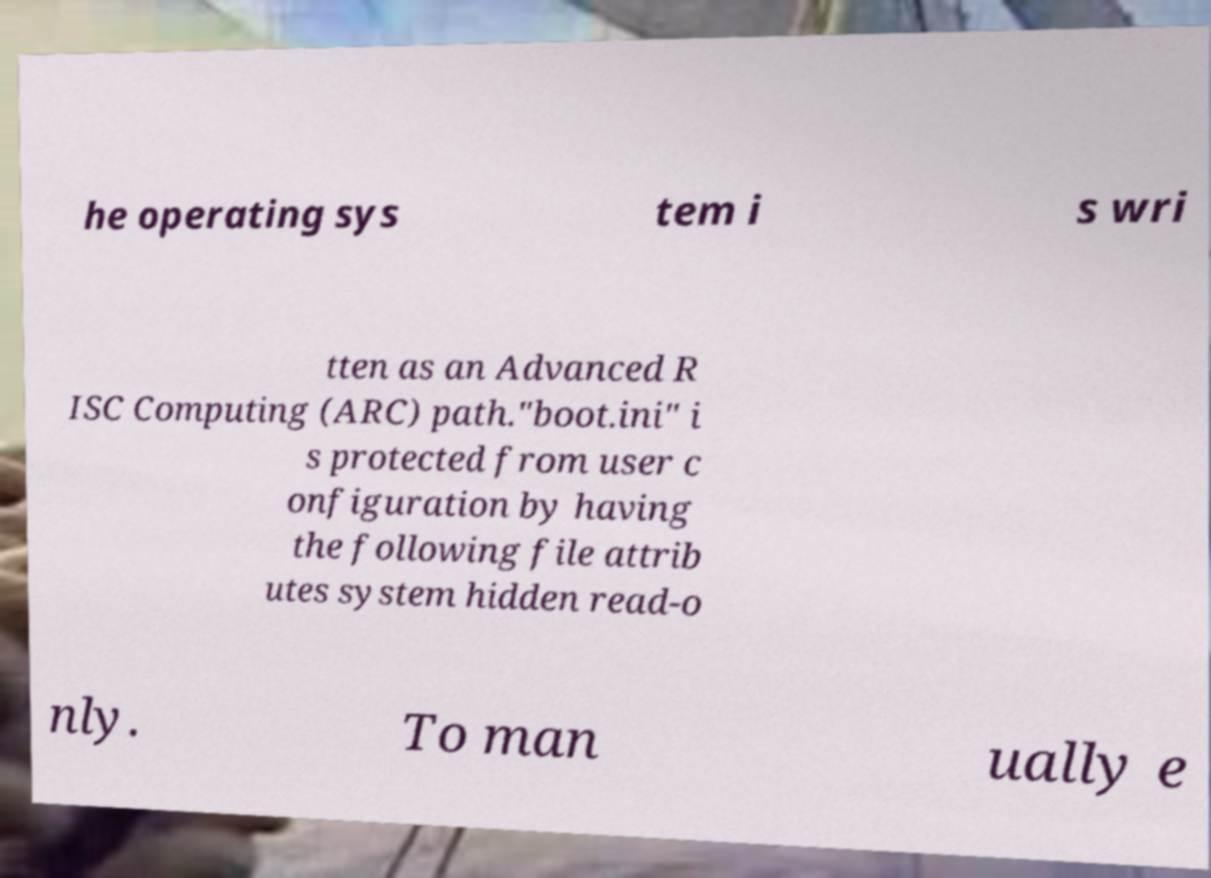There's text embedded in this image that I need extracted. Can you transcribe it verbatim? he operating sys tem i s wri tten as an Advanced R ISC Computing (ARC) path."boot.ini" i s protected from user c onfiguration by having the following file attrib utes system hidden read-o nly. To man ually e 